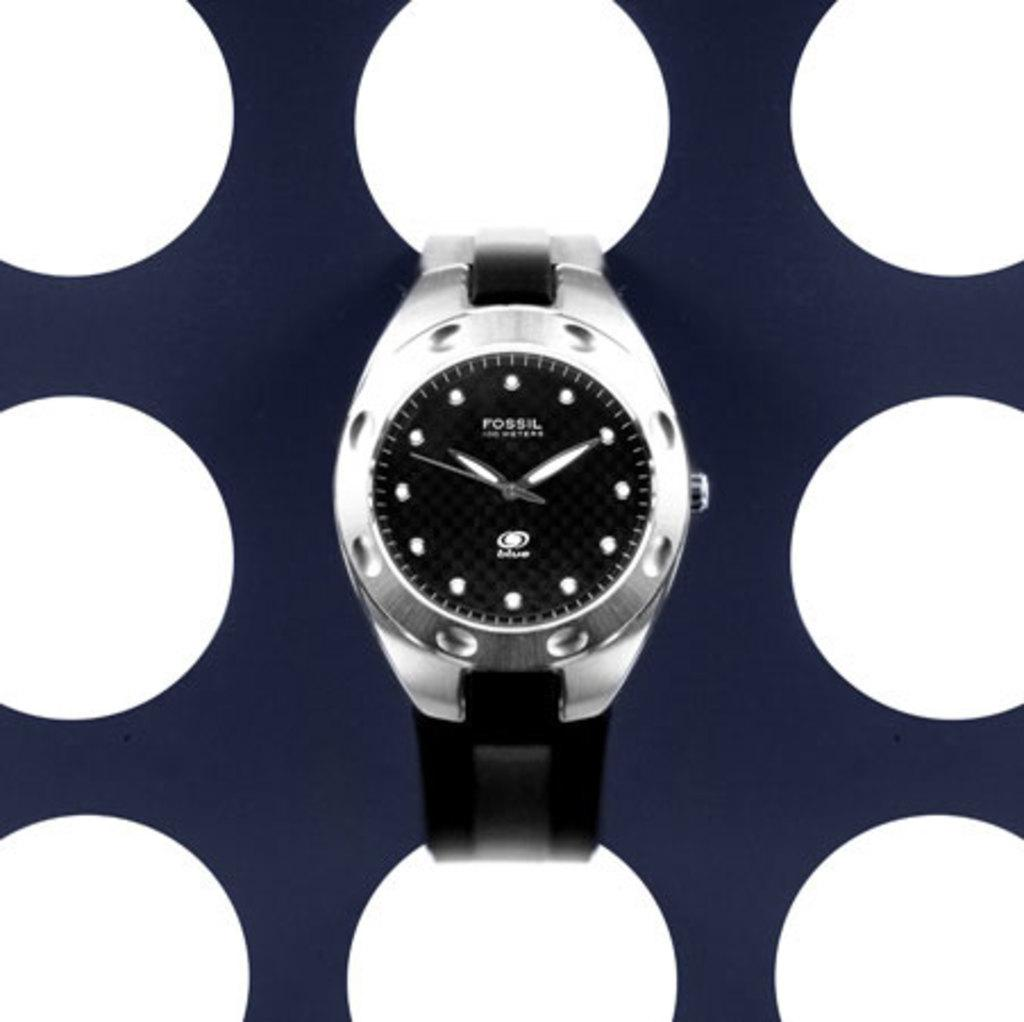<image>
Write a terse but informative summary of the picture. A fossil watch on a polk a dot back ground. 